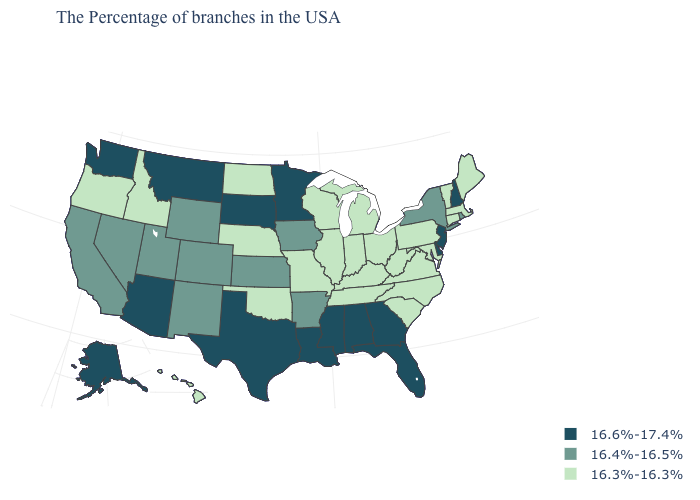Name the states that have a value in the range 16.6%-17.4%?
Short answer required. New Hampshire, New Jersey, Delaware, Florida, Georgia, Alabama, Mississippi, Louisiana, Minnesota, Texas, South Dakota, Montana, Arizona, Washington, Alaska. Among the states that border Montana , which have the lowest value?
Short answer required. North Dakota, Idaho. What is the value of Hawaii?
Be succinct. 16.3%-16.3%. Which states have the highest value in the USA?
Be succinct. New Hampshire, New Jersey, Delaware, Florida, Georgia, Alabama, Mississippi, Louisiana, Minnesota, Texas, South Dakota, Montana, Arizona, Washington, Alaska. Among the states that border Mississippi , does Louisiana have the lowest value?
Give a very brief answer. No. Does the first symbol in the legend represent the smallest category?
Give a very brief answer. No. Does the first symbol in the legend represent the smallest category?
Keep it brief. No. Name the states that have a value in the range 16.6%-17.4%?
Write a very short answer. New Hampshire, New Jersey, Delaware, Florida, Georgia, Alabama, Mississippi, Louisiana, Minnesota, Texas, South Dakota, Montana, Arizona, Washington, Alaska. Name the states that have a value in the range 16.6%-17.4%?
Write a very short answer. New Hampshire, New Jersey, Delaware, Florida, Georgia, Alabama, Mississippi, Louisiana, Minnesota, Texas, South Dakota, Montana, Arizona, Washington, Alaska. Name the states that have a value in the range 16.4%-16.5%?
Quick response, please. Rhode Island, New York, Arkansas, Iowa, Kansas, Wyoming, Colorado, New Mexico, Utah, Nevada, California. Does the map have missing data?
Write a very short answer. No. Which states have the lowest value in the South?
Answer briefly. Maryland, Virginia, North Carolina, South Carolina, West Virginia, Kentucky, Tennessee, Oklahoma. Which states hav the highest value in the South?
Quick response, please. Delaware, Florida, Georgia, Alabama, Mississippi, Louisiana, Texas. What is the value of Florida?
Write a very short answer. 16.6%-17.4%. Is the legend a continuous bar?
Quick response, please. No. 